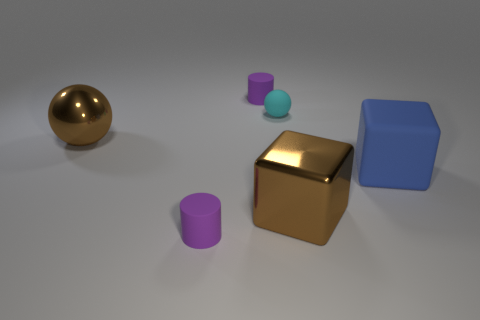What number of other objects are there of the same shape as the blue rubber object? There is one object that shares the same shape as the blue rubber object. It's the gold cube, which, like the blue object, has six faces, twelve edges, and eight vertices, making them both cubes. 